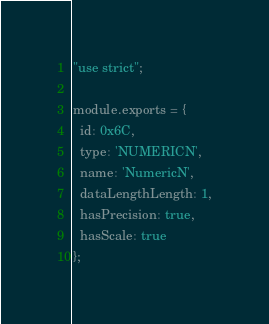<code> <loc_0><loc_0><loc_500><loc_500><_JavaScript_>"use strict";

module.exports = {
  id: 0x6C,
  type: 'NUMERICN',
  name: 'NumericN',
  dataLengthLength: 1,
  hasPrecision: true,
  hasScale: true
};</code> 